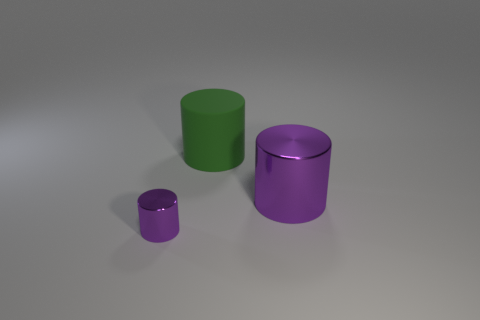Can you tell me what colors the cylinders are and how they differ in brightness? Sure! There are three cylinders with different colors. The smallest one is a dark shade of purple, and has a high gloss finish, making it appear very shiny. The medium-sized cylinder is a bright green color and it has a semi-gloss finish, giving it a moderate reflective surface. The largest cylinder has a matte purple finish, which reflects very little light, making it appear non-reflective and flatter in color compared to the others. 